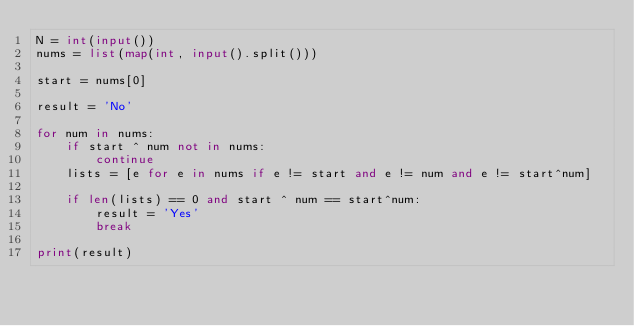<code> <loc_0><loc_0><loc_500><loc_500><_Python_>N = int(input())
nums = list(map(int, input().split()))

start = nums[0]

result = 'No'

for num in nums:
    if start ^ num not in nums:
        continue
    lists = [e for e in nums if e != start and e != num and e != start^num]

    if len(lists) == 0 and start ^ num == start^num:
        result = 'Yes'
        break

print(result)</code> 